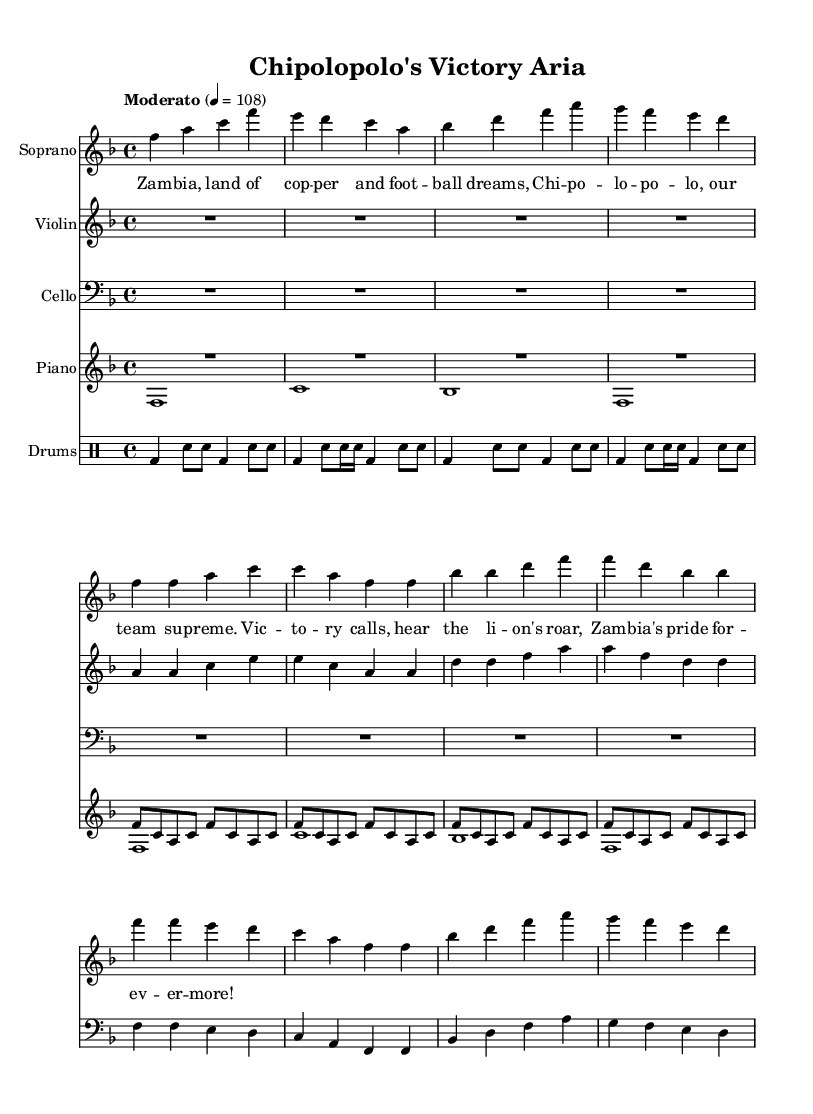What is the key signature of this music? The key signature is F major, which has one flat (B flat). This is determined by looking at the key signature symbol at the beginning of the score.
Answer: F major What is the time signature of this music? The time signature is 4/4, indicating there are four beats per measure, and the quarter note gets one beat. This can be identified at the beginning of the score where the time signature is placed.
Answer: 4/4 What is the tempo marking of the piece? The tempo marking indicates "Moderato," which suggests a moderate speed. This is found near the beginning of the score written above the staff.
Answer: Moderato How many measures are there in the soprano voice part? There are 8 measures in the soprano voice part, identifiable by counting the groupings of vertical lines that separate the musical phrases.
Answer: 8 What instruments are used in this opera piece? The instruments included are Soprano, Violin, Cello, Piano, and Drums. This can be seen at the beginning of each staff where the instrument names are indicated.
Answer: Soprano, Violin, Cello, Piano, Drums In which section do we find the lyrics for the chorus? The lyrics for the chorus are found after the section indicated as "chorus" in the lyric mode. This is laid out below the soprano part in the score as a separate verse.
Answer: After the soprano section What is the theme of the lyrics in the opera? The theme of the lyrics revolves around Zambian pride in football and celebrating a team victory, which can be understood by reviewing the text lines dedicated to expressing these emotions.
Answer: Zambian pride in football 